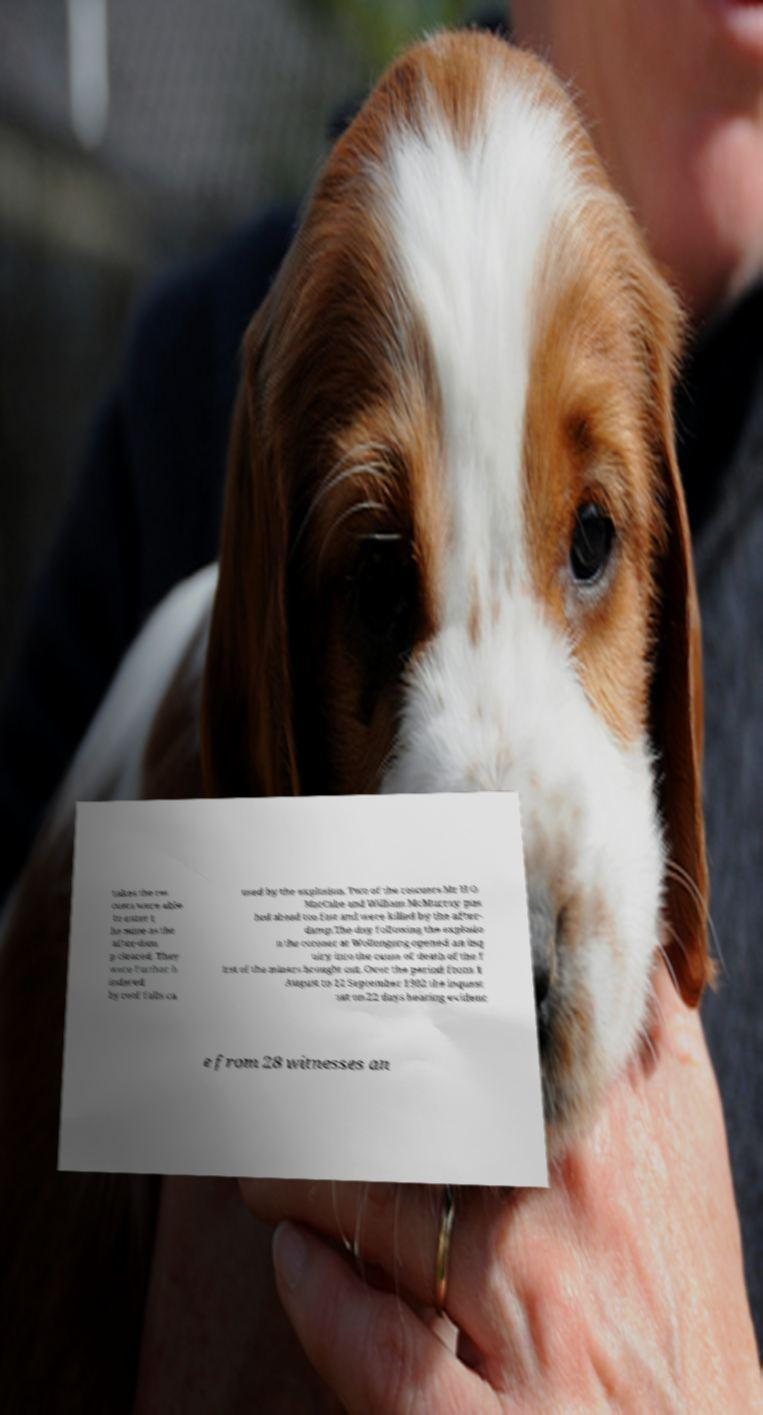I need the written content from this picture converted into text. Can you do that? takes the res cuers were able to enter t he mine as the after-dam p cleared. They were further h indered by roof falls ca used by the explosion. Two of the rescuers Mr H O MacCabe and William McMurray pus hed ahead too fast and were killed by the after- damp.The day following the explosio n the coroner at Wollongong opened an inq uiry into the cause of death of the f irst of the miners brought out. Over the period from 1 August to 12 September 1902 the inquest sat on 22 days hearing evidenc e from 28 witnesses an 